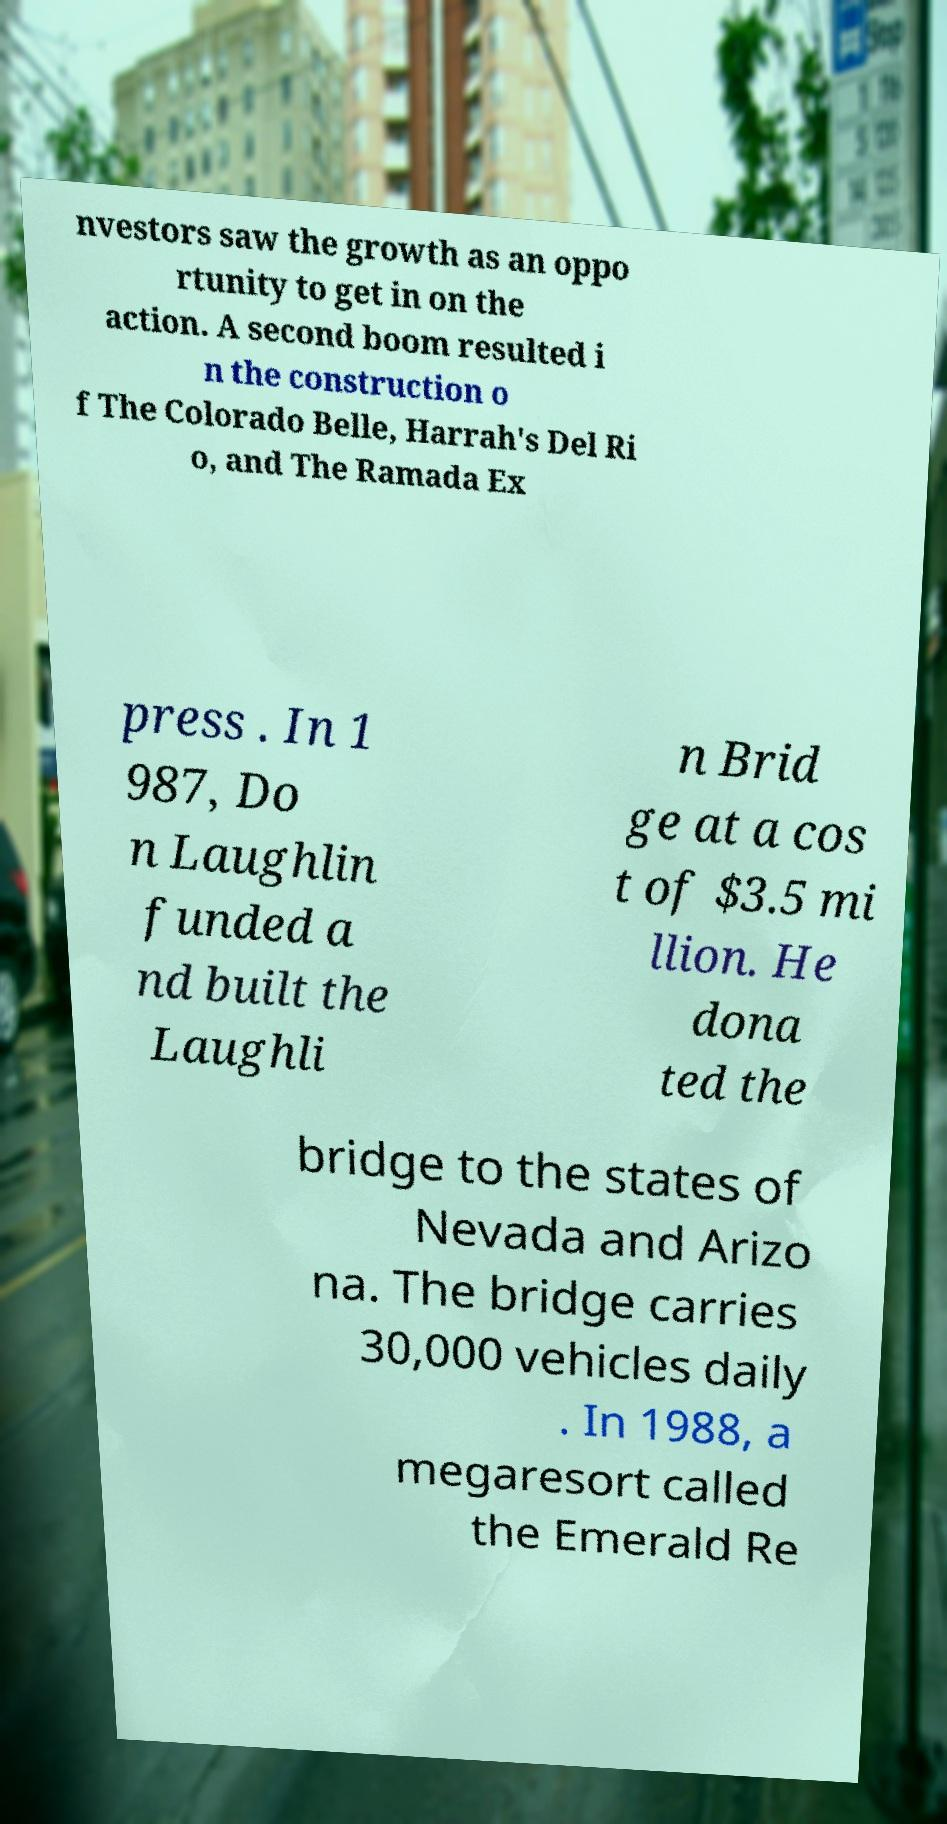What messages or text are displayed in this image? I need them in a readable, typed format. nvestors saw the growth as an oppo rtunity to get in on the action. A second boom resulted i n the construction o f The Colorado Belle, Harrah's Del Ri o, and The Ramada Ex press . In 1 987, Do n Laughlin funded a nd built the Laughli n Brid ge at a cos t of $3.5 mi llion. He dona ted the bridge to the states of Nevada and Arizo na. The bridge carries 30,000 vehicles daily . In 1988, a megaresort called the Emerald Re 